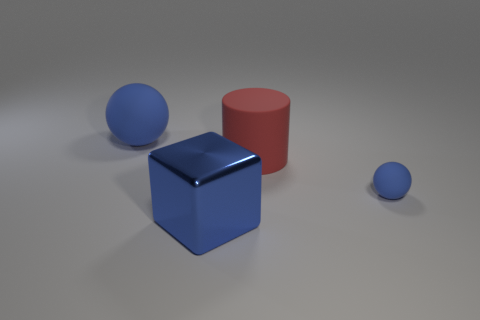There is a ball that is the same color as the tiny matte thing; what material is it?
Keep it short and to the point. Rubber. Does the small rubber thing have the same color as the big cube?
Give a very brief answer. Yes. Are there fewer tiny matte balls than blue matte spheres?
Provide a succinct answer. Yes. What color is the large object in front of the ball that is on the right side of the large blue sphere?
Offer a terse response. Blue. What material is the blue thing in front of the ball in front of the rubber object that is behind the cylinder made of?
Provide a short and direct response. Metal. Is the size of the blue sphere that is left of the metal object the same as the red thing?
Offer a very short reply. Yes. There is a big blue thing that is behind the large blue block; what material is it?
Provide a short and direct response. Rubber. Is the number of small objects greater than the number of big yellow rubber objects?
Offer a very short reply. Yes. What number of objects are big blue things that are in front of the tiny blue rubber ball or small brown cubes?
Provide a short and direct response. 1. There is a large blue thing that is to the left of the blue metal object; what number of blue objects are on the right side of it?
Your response must be concise. 2. 